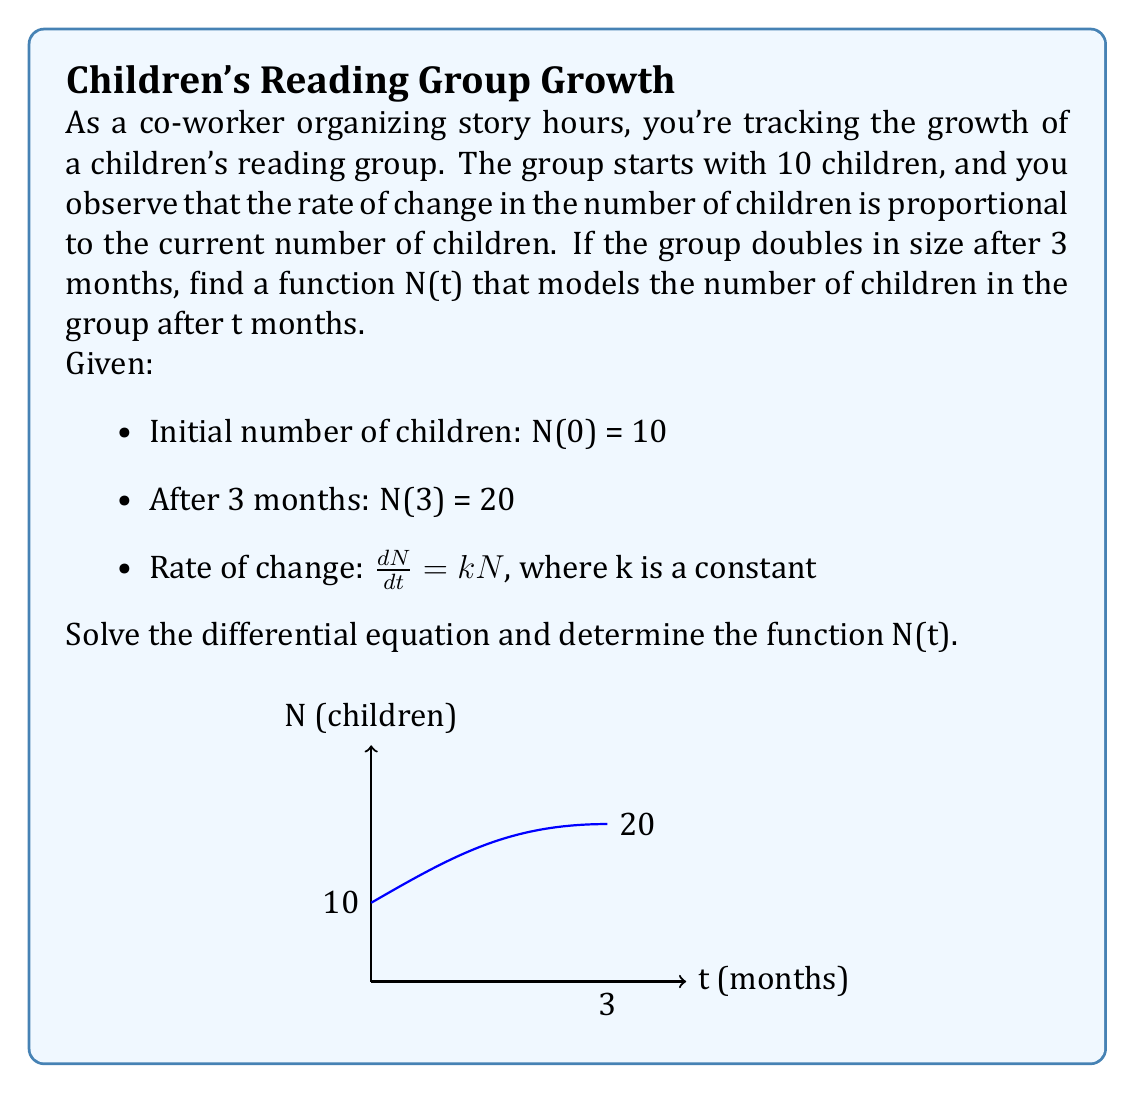What is the answer to this math problem? Let's solve this step-by-step:

1) We're given the differential equation: $\frac{dN}{dt} = kN$

2) This is a separable equation. Let's separate the variables:
   $\frac{dN}{N} = k dt$

3) Integrate both sides:
   $\int \frac{dN}{N} = \int k dt$
   $\ln|N| = kt + C$, where C is a constant of integration

4) Exponentiate both sides:
   $N = e^{kt + C} = e^C \cdot e^{kt}$
   Let $A = e^C$, then: $N = A e^{kt}$

5) Now we use the initial condition: N(0) = 10
   $10 = A e^{k(0)} = A$

6) So our general solution is: $N(t) = 10e^{kt}$

7) To find k, we use the condition that N(3) = 20:
   $20 = 10e^{k(3)}$
   $2 = e^{3k}$
   $\ln(2) = 3k$
   $k = \frac{\ln(2)}{3}$

8) Therefore, our final solution is:
   $N(t) = 10e^{\frac{\ln(2)}{3}t}$

This function models the number of children in the reading group after t months.
Answer: $N(t) = 10e^{\frac{\ln(2)}{3}t}$ 